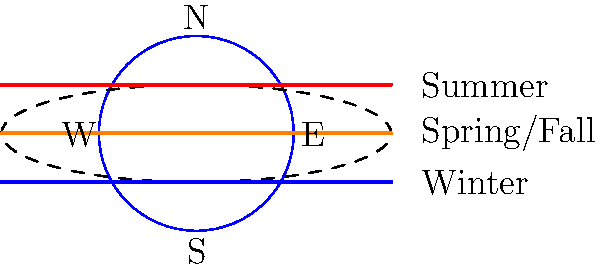As an event manager in Las Vegas, you're planning an outdoor stargazing event for a corporate client. How does the Sun's apparent path across the sky differ between summer and winter, and how might this affect your event planning? 1. The Sun's apparent path across the sky changes due to Earth's axial tilt and its orbit around the Sun.

2. In summer:
   - The Sun's path is higher in the sky.
   - It rises further northeast and sets further northwest.
   - Daylight hours are longer.

3. In winter:
   - The Sun's path is lower in the sky.
   - It rises further southeast and sets further southwest.
   - Daylight hours are shorter.

4. This difference is due to the Earth's axial tilt of approximately 23.5°.

5. The Sun's path is highest at the summer solstice and lowest at the winter solstice.

6. During equinoxes (spring and fall), the Sun's path is in between these extremes.

7. For event planning in Las Vegas:
   - Summer: Longer daylight hours, higher temperatures, more shade needed.
   - Winter: Shorter daylight hours, cooler temperatures, less shade required.
   - Consider sunset times for optimal stargazing conditions.
   - Plan for appropriate lighting and temperature control based on the season.

8. The latitude of Las Vegas (about 36°N) means these seasonal differences are quite noticeable, though not as extreme as locations closer to the poles.
Answer: Higher and longer path in summer, lower and shorter in winter; affects daylight hours and event conditions. 